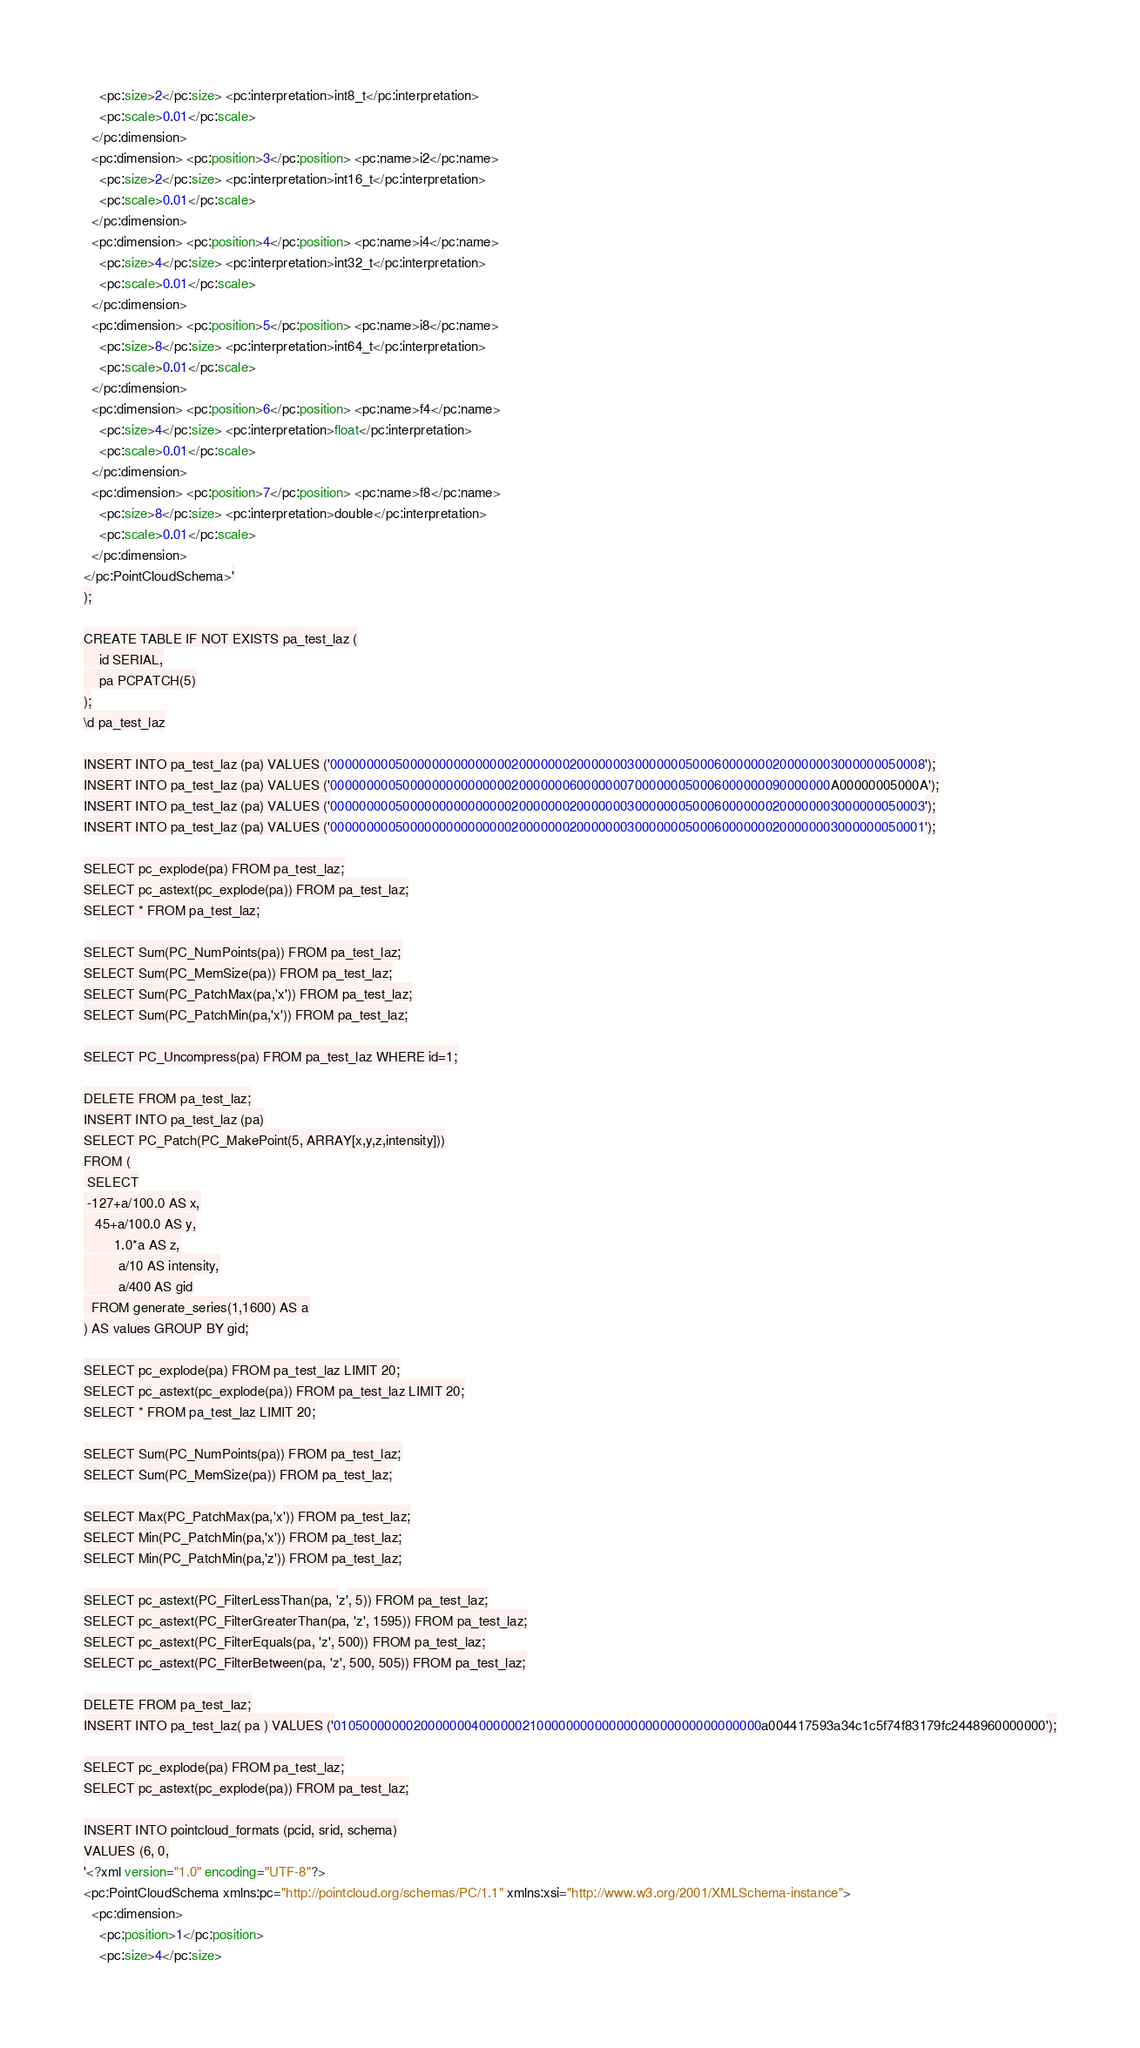Convert code to text. <code><loc_0><loc_0><loc_500><loc_500><_SQL_>    <pc:size>2</pc:size> <pc:interpretation>int8_t</pc:interpretation>
    <pc:scale>0.01</pc:scale>
  </pc:dimension>
  <pc:dimension> <pc:position>3</pc:position> <pc:name>i2</pc:name>
    <pc:size>2</pc:size> <pc:interpretation>int16_t</pc:interpretation>
    <pc:scale>0.01</pc:scale>
  </pc:dimension>
  <pc:dimension> <pc:position>4</pc:position> <pc:name>i4</pc:name>
    <pc:size>4</pc:size> <pc:interpretation>int32_t</pc:interpretation>
    <pc:scale>0.01</pc:scale>
  </pc:dimension>
  <pc:dimension> <pc:position>5</pc:position> <pc:name>i8</pc:name>
    <pc:size>8</pc:size> <pc:interpretation>int64_t</pc:interpretation>
    <pc:scale>0.01</pc:scale>
  </pc:dimension>
  <pc:dimension> <pc:position>6</pc:position> <pc:name>f4</pc:name>
    <pc:size>4</pc:size> <pc:interpretation>float</pc:interpretation>
    <pc:scale>0.01</pc:scale>
  </pc:dimension>
  <pc:dimension> <pc:position>7</pc:position> <pc:name>f8</pc:name>
    <pc:size>8</pc:size> <pc:interpretation>double</pc:interpretation>
    <pc:scale>0.01</pc:scale>
  </pc:dimension>
</pc:PointCloudSchema>'
);

CREATE TABLE IF NOT EXISTS pa_test_laz (
	id SERIAL,
    pa PCPATCH(5)
);
\d pa_test_laz

INSERT INTO pa_test_laz (pa) VALUES ('0000000005000000000000000200000002000000030000000500060000000200000003000000050008');
INSERT INTO pa_test_laz (pa) VALUES ('000000000500000000000000020000000600000007000000050006000000090000000A00000005000A');
INSERT INTO pa_test_laz (pa) VALUES ('0000000005000000000000000200000002000000030000000500060000000200000003000000050003');
INSERT INTO pa_test_laz (pa) VALUES ('0000000005000000000000000200000002000000030000000500060000000200000003000000050001');

SELECT pc_explode(pa) FROM pa_test_laz;
SELECT pc_astext(pc_explode(pa)) FROM pa_test_laz;
SELECT * FROM pa_test_laz;

SELECT Sum(PC_NumPoints(pa)) FROM pa_test_laz;
SELECT Sum(PC_MemSize(pa)) FROM pa_test_laz;
SELECT Sum(PC_PatchMax(pa,'x')) FROM pa_test_laz;
SELECT Sum(PC_PatchMin(pa,'x')) FROM pa_test_laz;

SELECT PC_Uncompress(pa) FROM pa_test_laz WHERE id=1;

DELETE FROM pa_test_laz;
INSERT INTO pa_test_laz (pa)
SELECT PC_Patch(PC_MakePoint(5, ARRAY[x,y,z,intensity]))
FROM (
 SELECT
 -127+a/100.0 AS x,
   45+a/100.0 AS y,
        1.0*a AS z,
         a/10 AS intensity,
         a/400 AS gid
  FROM generate_series(1,1600) AS a
) AS values GROUP BY gid;

SELECT pc_explode(pa) FROM pa_test_laz LIMIT 20;
SELECT pc_astext(pc_explode(pa)) FROM pa_test_laz LIMIT 20;
SELECT * FROM pa_test_laz LIMIT 20;

SELECT Sum(PC_NumPoints(pa)) FROM pa_test_laz;
SELECT Sum(PC_MemSize(pa)) FROM pa_test_laz;

SELECT Max(PC_PatchMax(pa,'x')) FROM pa_test_laz;
SELECT Min(PC_PatchMin(pa,'x')) FROM pa_test_laz;
SELECT Min(PC_PatchMin(pa,'z')) FROM pa_test_laz;

SELECT pc_astext(PC_FilterLessThan(pa, 'z', 5)) FROM pa_test_laz;
SELECT pc_astext(PC_FilterGreaterThan(pa, 'z', 1595)) FROM pa_test_laz;
SELECT pc_astext(PC_FilterEquals(pa, 'z', 500)) FROM pa_test_laz;
SELECT pc_astext(PC_FilterBetween(pa, 'z', 500, 505)) FROM pa_test_laz;

DELETE FROM pa_test_laz;
INSERT INTO pa_test_laz( pa ) VALUES ('01050000000200000004000000210000000000000000000000000000000a004417593a34c1c5f74f83179fc2448960000000');

SELECT pc_explode(pa) FROM pa_test_laz;
SELECT pc_astext(pc_explode(pa)) FROM pa_test_laz;

INSERT INTO pointcloud_formats (pcid, srid, schema)
VALUES (6, 0,
'<?xml version="1.0" encoding="UTF-8"?>
<pc:PointCloudSchema xmlns:pc="http://pointcloud.org/schemas/PC/1.1" xmlns:xsi="http://www.w3.org/2001/XMLSchema-instance">
  <pc:dimension>
    <pc:position>1</pc:position>
    <pc:size>4</pc:size></code> 